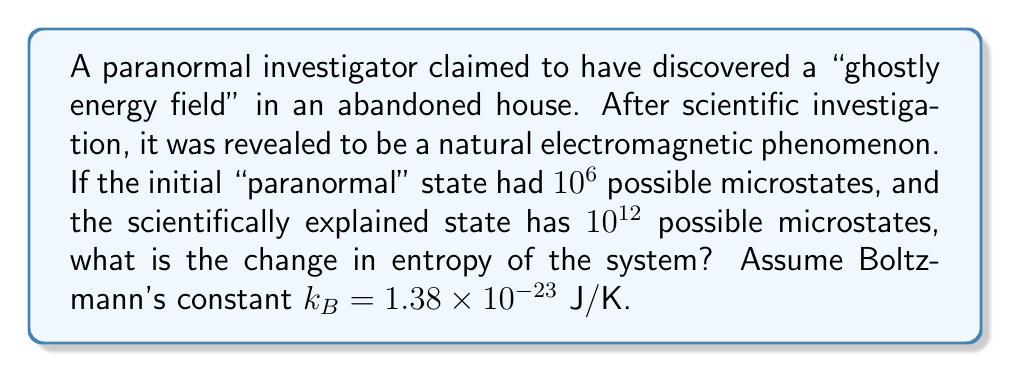Can you solve this math problem? 1) The entropy of a system is given by Boltzmann's equation:

   $$S = k_B \ln \Omega$$

   where $S$ is entropy, $k_B$ is Boltzmann's constant, and $\Omega$ is the number of microstates.

2) For the initial "paranormal" state:
   $$S_1 = k_B \ln (10^6)$$

3) For the final scientifically explained state:
   $$S_2 = k_B \ln (10^{12})$$

4) The change in entropy is:
   $$\Delta S = S_2 - S_1 = k_B \ln (10^{12}) - k_B \ln (10^6)$$

5) Using the logarithm property $\ln(a) - \ln(b) = \ln(a/b)$:
   $$\Delta S = k_B \ln (10^{12} / 10^6) = k_B \ln (10^6)$$

6) Simplify:
   $$\Delta S = k_B \cdot 6 \ln (10)$$

7) Substitute the value of $k_B$:
   $$\Delta S = 1.38 \times 10^{-23} \cdot 6 \cdot 2.303$$

8) Calculate:
   $$\Delta S = 1.91 \times 10^{-22} \text{ J/K}$$
Answer: $1.91 \times 10^{-22} \text{ J/K}$ 